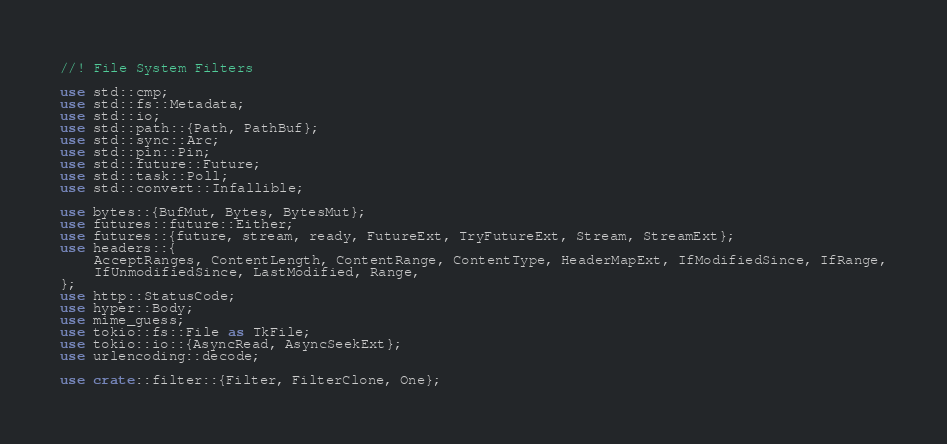<code> <loc_0><loc_0><loc_500><loc_500><_Rust_>//! File System Filters

use std::cmp;
use std::fs::Metadata;
use std::io;
use std::path::{Path, PathBuf};
use std::sync::Arc;
use std::pin::Pin;
use std::future::Future;
use std::task::Poll;
use std::convert::Infallible;

use bytes::{BufMut, Bytes, BytesMut};
use futures::future::Either;
use futures::{future, stream, ready, FutureExt, TryFutureExt, Stream, StreamExt};
use headers::{
    AcceptRanges, ContentLength, ContentRange, ContentType, HeaderMapExt, IfModifiedSince, IfRange,
    IfUnmodifiedSince, LastModified, Range,
};
use http::StatusCode;
use hyper::Body;
use mime_guess;
use tokio::fs::File as TkFile;
use tokio::io::{AsyncRead, AsyncSeekExt};
use urlencoding::decode;

use crate::filter::{Filter, FilterClone, One};</code> 